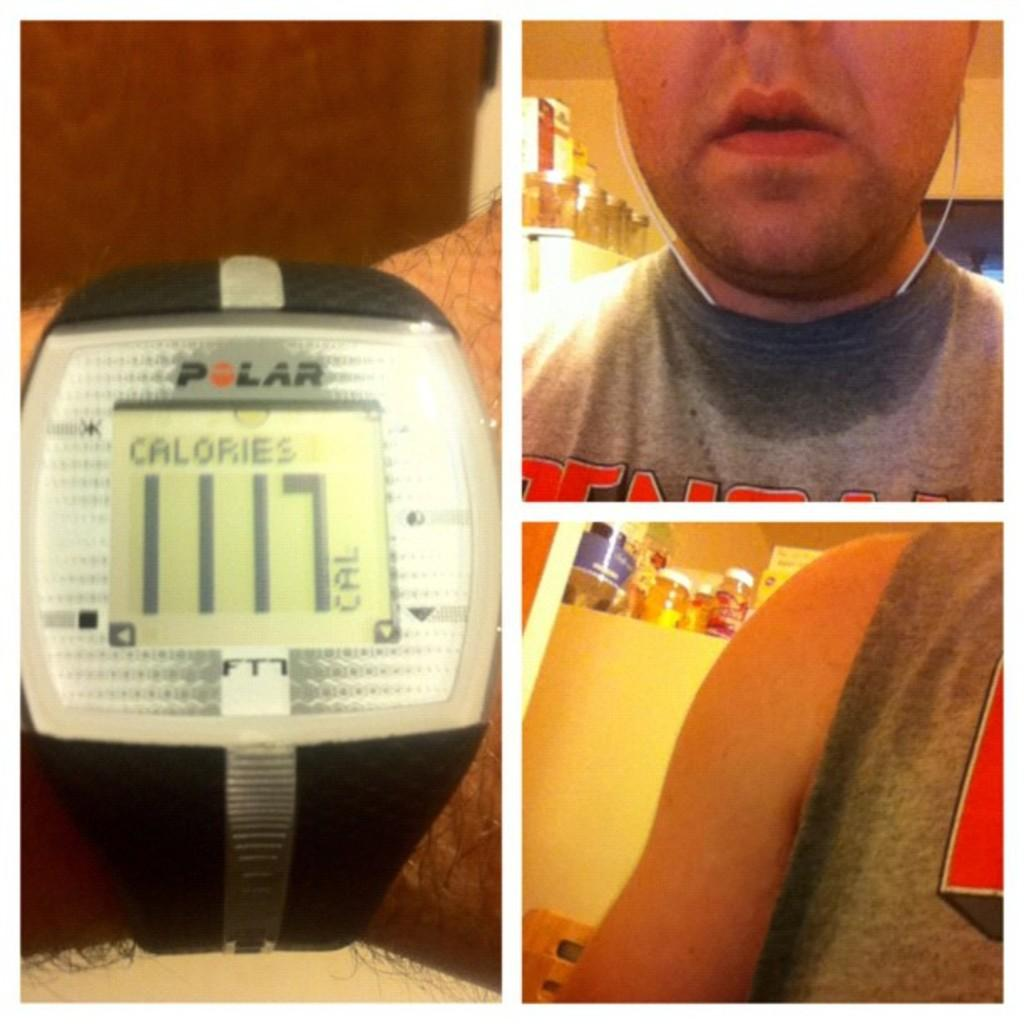<image>
Provide a brief description of the given image. Several pictures of a man and a watch showing calories. 